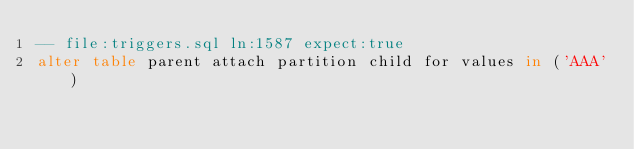Convert code to text. <code><loc_0><loc_0><loc_500><loc_500><_SQL_>-- file:triggers.sql ln:1587 expect:true
alter table parent attach partition child for values in ('AAA')
</code> 